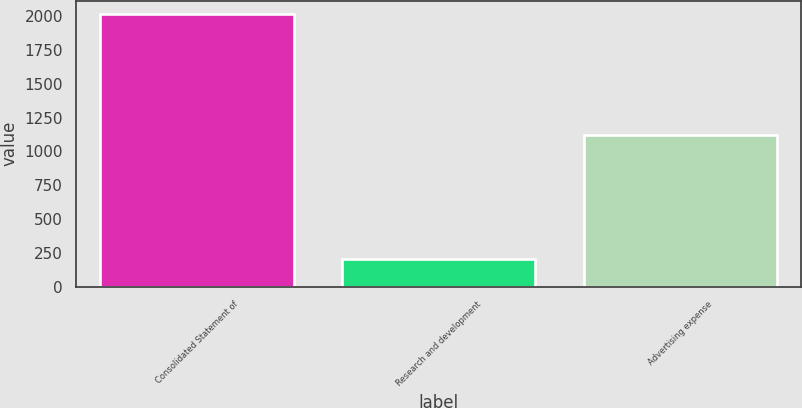Convert chart to OTSL. <chart><loc_0><loc_0><loc_500><loc_500><bar_chart><fcel>Consolidated Statement of<fcel>Research and development<fcel>Advertising expense<nl><fcel>2012<fcel>206<fcel>1120<nl></chart> 